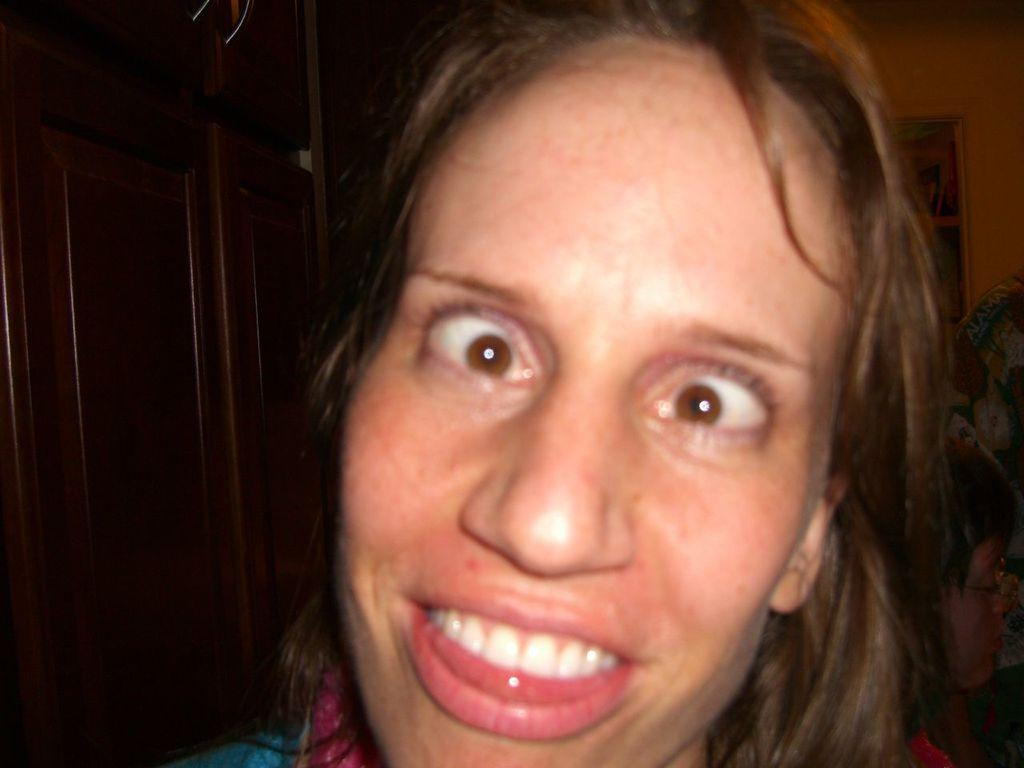Who is present in the image? There is a woman in the image. What can be observed about the woman's facial expression? The woman has an expression on her face. What type of furniture can be seen in the background of the image? There is a shelf and a cupboard in the background of the image. What is located on the right side of the image? There are objects on the right side of the image. What type of event is the woman attending in the image? There is no indication of an event in the image; it simply shows a woman with a facial expression and objects in the background. What drink is the woman holding in the image? There is no drink visible in the image; the woman does not appear to be holding anything. 